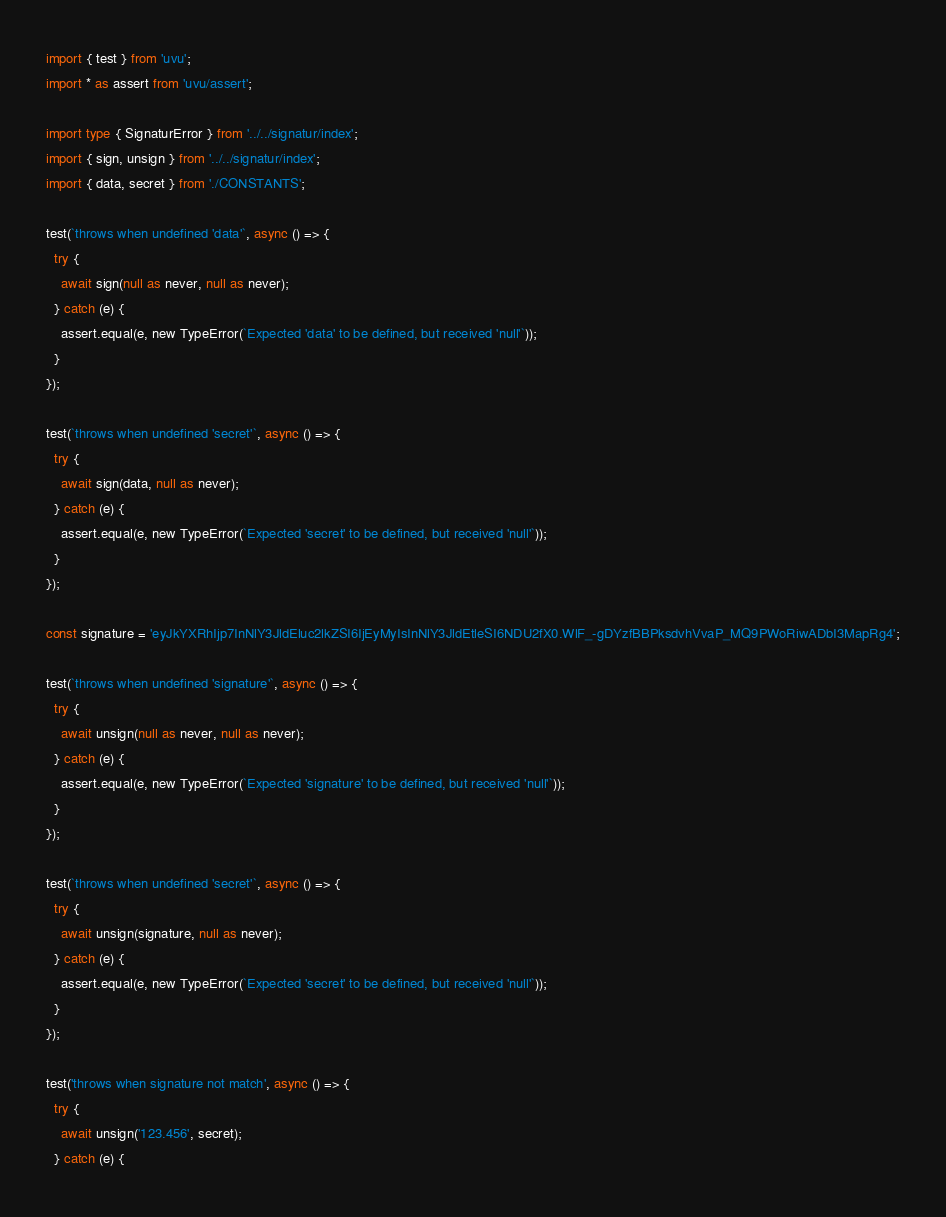Convert code to text. <code><loc_0><loc_0><loc_500><loc_500><_TypeScript_>import { test } from 'uvu';
import * as assert from 'uvu/assert';

import type { SignaturError } from '../../signatur/index';
import { sign, unsign } from '../../signatur/index';
import { data, secret } from './CONSTANTS';

test(`throws when undefined 'data'`, async () => {
  try {
    await sign(null as never, null as never);
  } catch (e) {
    assert.equal(e, new TypeError(`Expected 'data' to be defined, but received 'null'`));
  }
});

test(`throws when undefined 'secret'`, async () => {
  try {
    await sign(data, null as never);
  } catch (e) {
    assert.equal(e, new TypeError(`Expected 'secret' to be defined, but received 'null'`));
  }
});

const signature = 'eyJkYXRhIjp7InNlY3JldEluc2lkZSI6IjEyMyIsInNlY3JldEtleSI6NDU2fX0.WlF_-gDYzfBBPksdvhVvaP_MQ9PWoRiwADbI3MapRg4';

test(`throws when undefined 'signature'`, async () => {
  try {
    await unsign(null as never, null as never);
  } catch (e) {
    assert.equal(e, new TypeError(`Expected 'signature' to be defined, but received 'null'`));
  }
});

test(`throws when undefined 'secret'`, async () => {
  try {
    await unsign(signature, null as never);
  } catch (e) {
    assert.equal(e, new TypeError(`Expected 'secret' to be defined, but received 'null'`));
  }
});

test('throws when signature not match', async () => {
  try {
    await unsign('123.456', secret);
  } catch (e) {</code> 